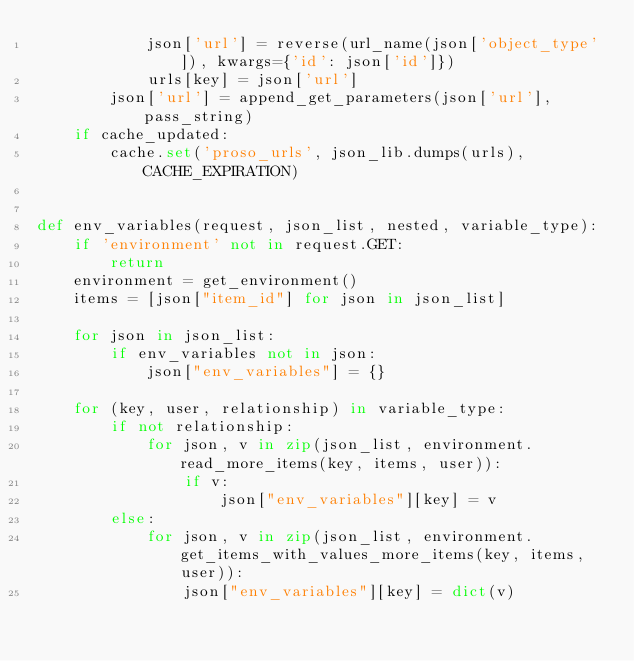<code> <loc_0><loc_0><loc_500><loc_500><_Python_>            json['url'] = reverse(url_name(json['object_type']), kwargs={'id': json['id']})
            urls[key] = json['url']
        json['url'] = append_get_parameters(json['url'], pass_string)
    if cache_updated:
        cache.set('proso_urls', json_lib.dumps(urls), CACHE_EXPIRATION)


def env_variables(request, json_list, nested, variable_type):
    if 'environment' not in request.GET:
        return
    environment = get_environment()
    items = [json["item_id"] for json in json_list]

    for json in json_list:
        if env_variables not in json:
            json["env_variables"] = {}

    for (key, user, relationship) in variable_type:
        if not relationship:
            for json, v in zip(json_list, environment.read_more_items(key, items, user)):
                if v:
                    json["env_variables"][key] = v
        else:
            for json, v in zip(json_list, environment.get_items_with_values_more_items(key, items, user)):
                json["env_variables"][key] = dict(v)
</code> 